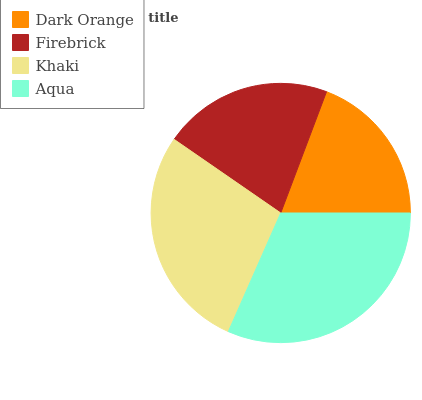Is Dark Orange the minimum?
Answer yes or no. Yes. Is Aqua the maximum?
Answer yes or no. Yes. Is Firebrick the minimum?
Answer yes or no. No. Is Firebrick the maximum?
Answer yes or no. No. Is Firebrick greater than Dark Orange?
Answer yes or no. Yes. Is Dark Orange less than Firebrick?
Answer yes or no. Yes. Is Dark Orange greater than Firebrick?
Answer yes or no. No. Is Firebrick less than Dark Orange?
Answer yes or no. No. Is Khaki the high median?
Answer yes or no. Yes. Is Firebrick the low median?
Answer yes or no. Yes. Is Aqua the high median?
Answer yes or no. No. Is Dark Orange the low median?
Answer yes or no. No. 